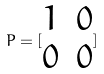<formula> <loc_0><loc_0><loc_500><loc_500>P = [ \begin{matrix} 1 & 0 \\ 0 & 0 \end{matrix} ]</formula> 